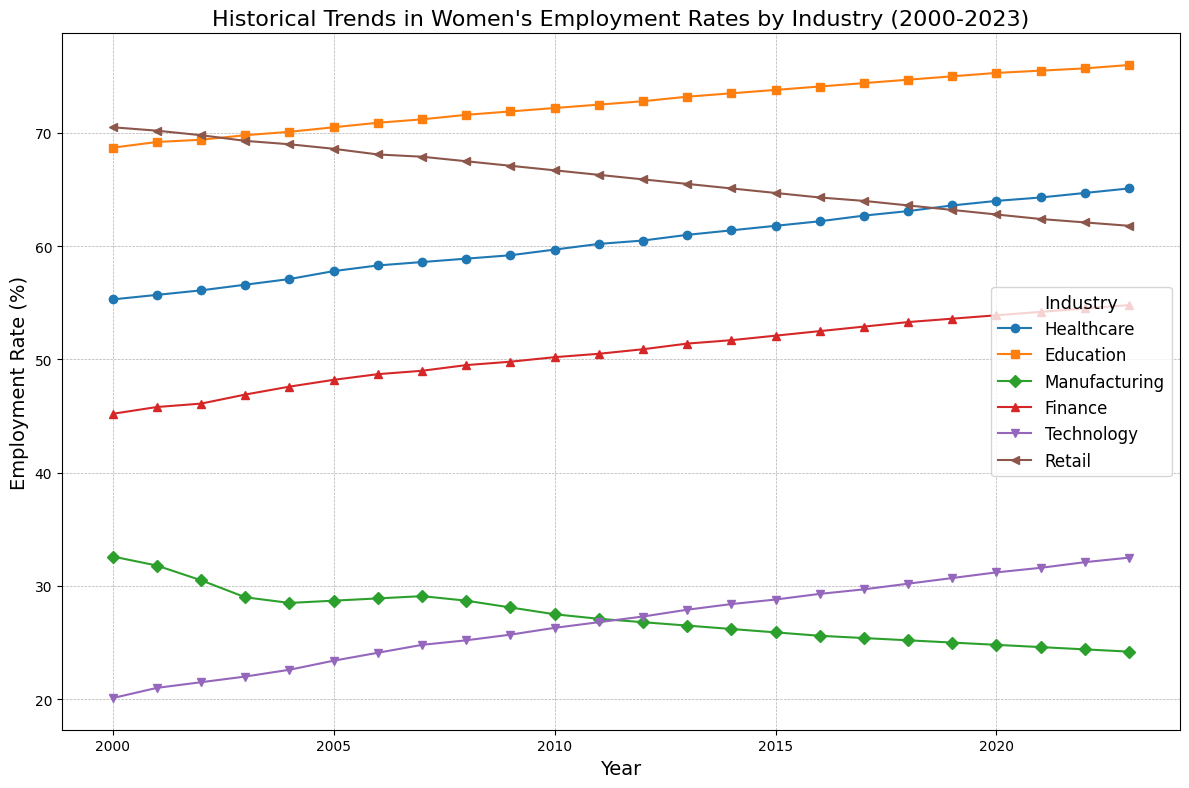What trend do you observe in women's employment rates in Healthcare from 2000 to 2023? By looking at the line for Healthcare, you can see a consistent upward trend. It starts at 55.3% in 2000 and rises each year to reach 65.1% in 2023.
Answer: An upward trend Which industry had the highest women's employment rate in 2023? The line that is highest in the year 2023 belongs to Education, which is at 76.0%.
Answer: Education Between 2005 and 2010, which industry showed the most significant decline in women's employment rates? Manufacturing line shows the most significant decline. It goes from 28.7% in 2005 to 27.5% in 2010.
Answer: Manufacturing How much did women's employment increase in Technology from 2000 to 2023? In 2000, the employment rate in Technology was 20.1%. In 2023, it is 32.5%. The increase is 32.5% - 20.1% = 12.4%.
Answer: 12.4% What is the average of women's employment rates in Finance for the years 2010, 2015, and 2020? The employment rates in Finance for 2010, 2015, and 2020 are 50.2%, 52.1%, and 53.9%, respectively. The average is (50.2 + 52.1 + 53.9) / 3 = 52.07%.
Answer: 52.07% In which year did Education surpass a 70% employment rate for women? Looking at the Education line, it first surpasses 70% in 2003, when it is at 69.8% and then goes to 70.1% in 2004.
Answer: 2004 Which industry had the most stable employment rate for women, showing the least volatility? Retail shows the least volatility as its line is relatively flat compared to the other industries, ranging narrowly around 70.5% to 61.8% from 2000 to 2023.
Answer: Retail By what percentage did the employment rate for women in Healthcare grow annually on average between 2000 and 2023? Initial rate in 2000 for Healthcare is 55.3%, and in 2023 it is 65.1%. The annual growth rate is (65.1 - 55.3) / (2023 - 2000) = 9.8 / 23 = approximately 0.426%.
Answer: 0.426% If you combine the average women's employment rates for Manufacturing and Technology in 2023, what percentage do you get? Manufacturing rate in 2023 is 24.2%, and Technology rate is 32.5%. The average is (24.2 + 32.5) / 2 = 28.35%.
Answer: 28.35% Which two industries experienced the closest employment rates for women in the year 2019, and what were those rates? In 2019, Finance and Technology had close employment rates, with Finance at 53.6% and Technology at 30.7%.
Answer: Finance (53.6%) and Technology (30.7%) 